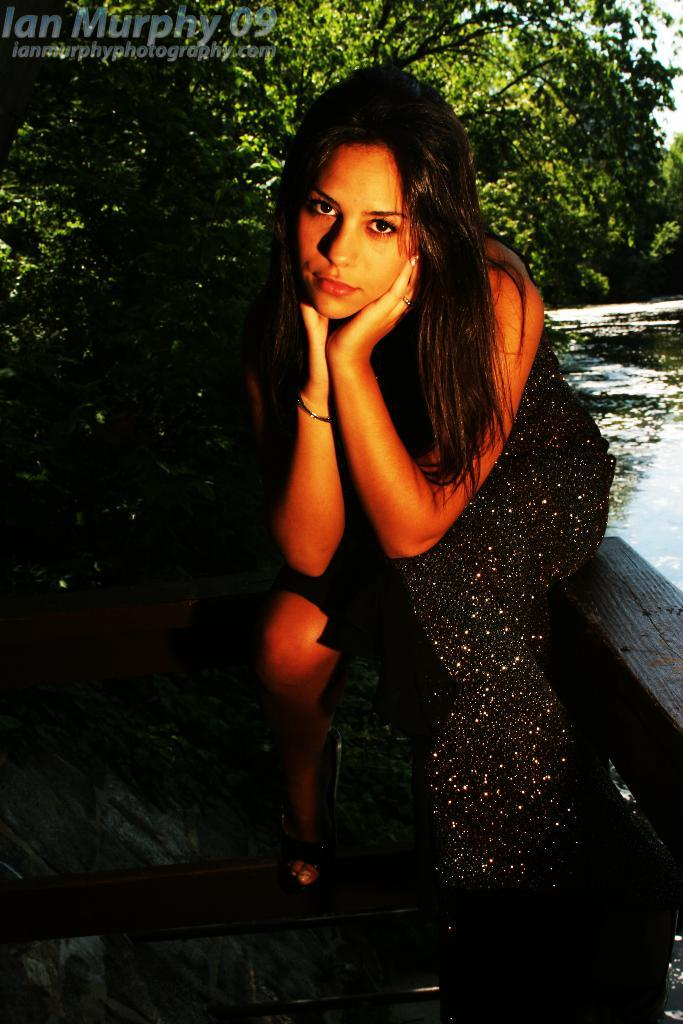What is the lady in the image doing? The lady is sitting in the image. What can be seen in the background of the image? There are trees and water visible in the background of the image. Can you describe the watermark in the image? There is a watermark in the left top corner of the image. What guide is the lady holding in the image? There is no guide visible in the image. 